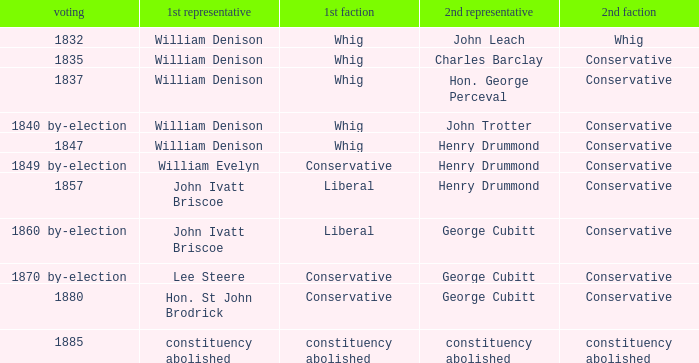Which party's 1st member is John Ivatt Briscoe in an election in 1857? Liberal. 